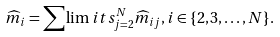Convert formula to latex. <formula><loc_0><loc_0><loc_500><loc_500>\widehat { m } _ { i } = \sum \lim i t s _ { j = 2 } ^ { N } \widehat { m } _ { i j } , i \in \{ 2 , 3 , \dots , N \} .</formula> 